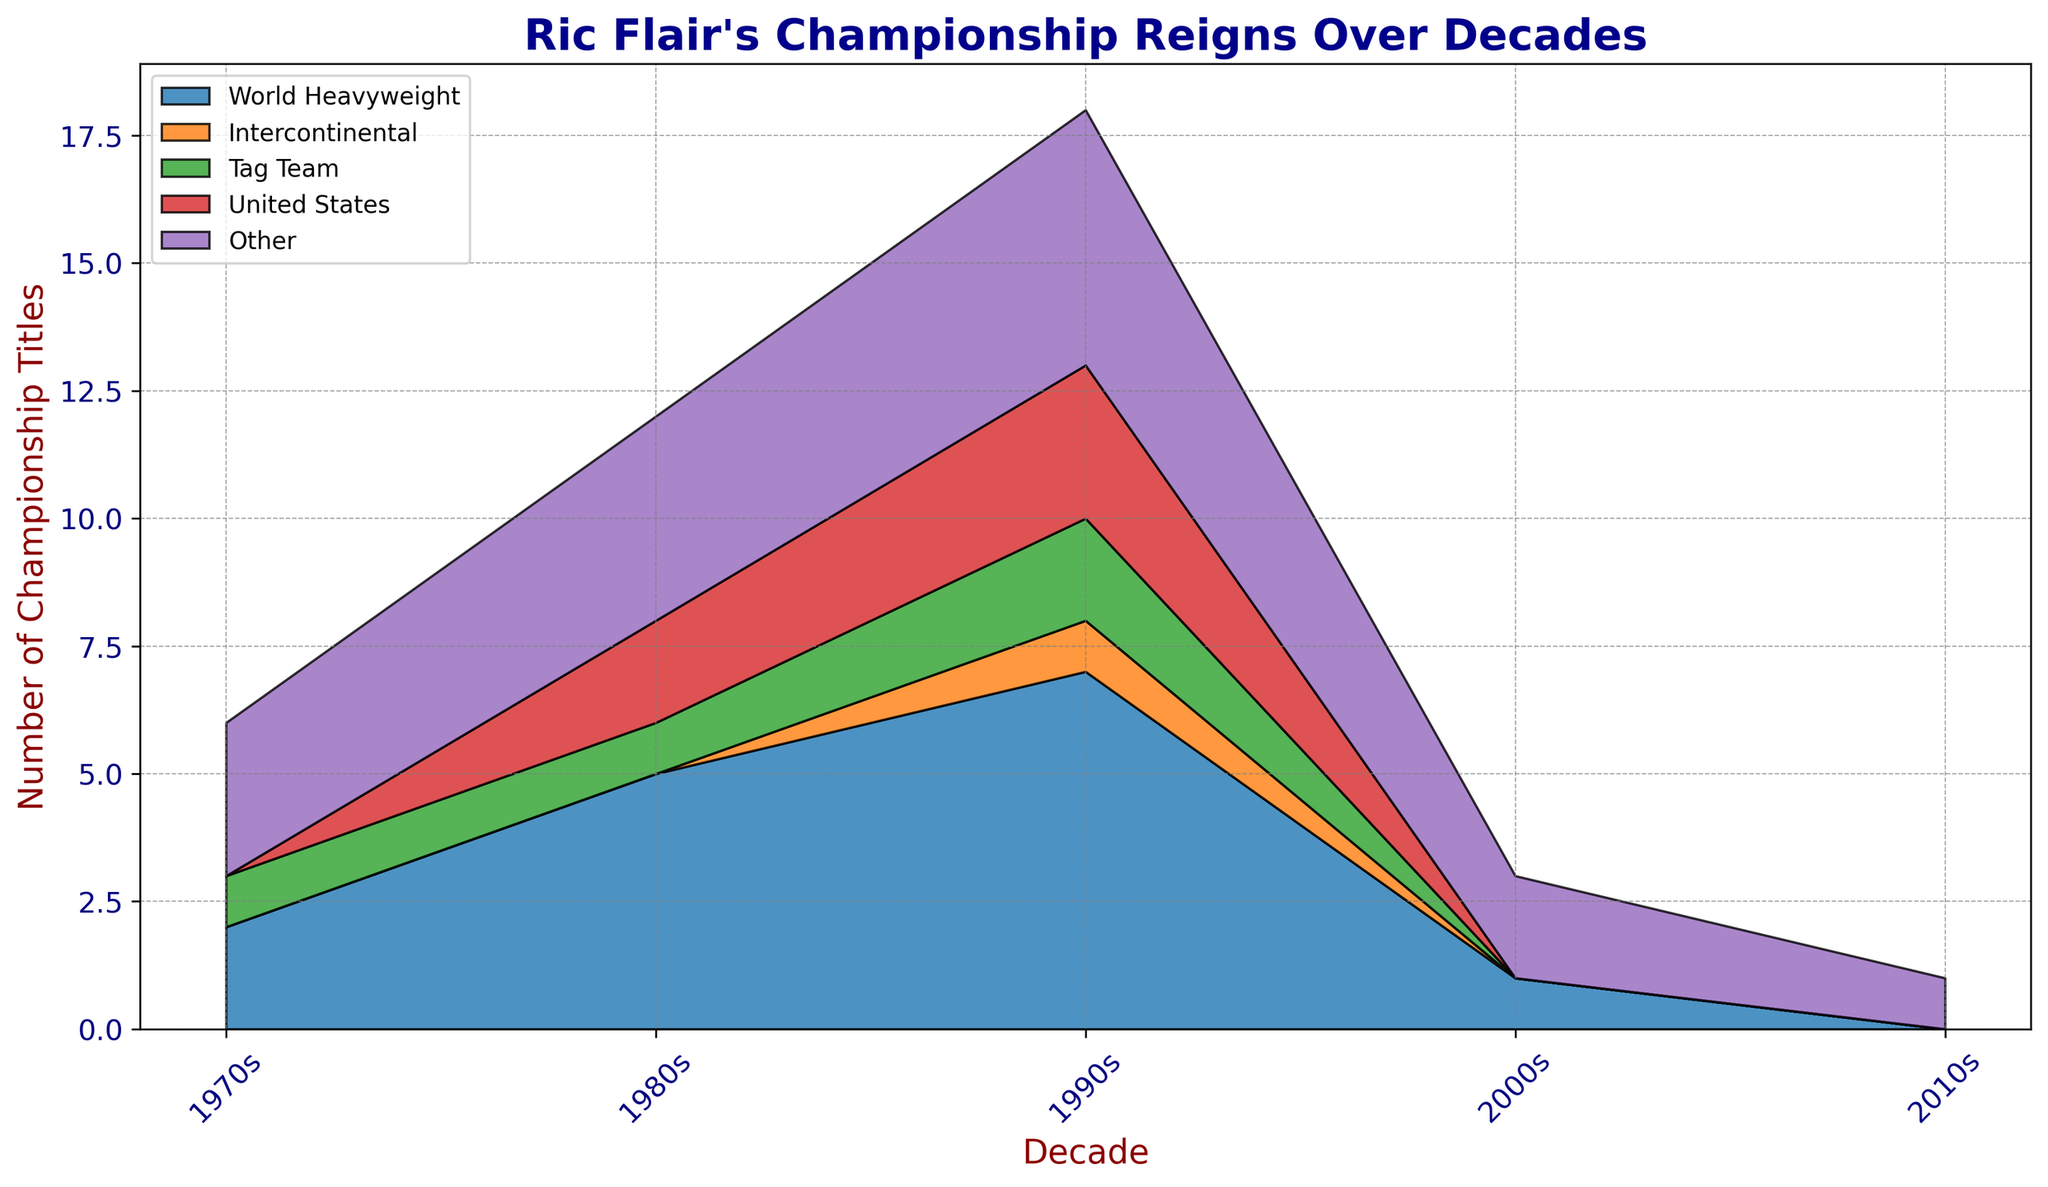What is the total number of championship titles Ric Flair won in the 1980s? To find the total number of titles in the 1980s, sum up all the values for that decade: World Heavyweight (5) + Intercontinental (0) + Tag Team (1) + United States (2) + Other (4). Therefore, 5 + 0 + 1 + 2 + 4 = 12.
Answer: 12 How many more World Heavyweight titles did Ric Flair win in the 1990s compared to the 2000s? To determine the difference, subtract the number of World Heavyweight titles in the 2000s from the number in the 1990s: 7 (1990s) - 1 (2000s).
Answer: 6 Which decade saw the highest number of United States Championship reigns? Look at the United States category across all decades and identify the highest value, which is in the 1990s with 3 titles.
Answer: 1990s In which decades did Ric Flair win at least one Tag Team Championship? Observe the Tag Team category for all decades and note the ones with values greater than zero: 1970s (1), 1980s (1), 1990s (2).
Answer: 1970s, 1980s, 1990s What is the total number of titles, across all categories, that Ric Flair won in the 1970s and 2010s combined? Sum up all title values for both decades: 
1970s: 2 (World Heavyweight) + 0 (Intercontinental) + 1 (Tag Team) + 0 (United States) + 3 (Other) = 6 
2010s: 0 (World Heavyweight) + 0 (Intercontinental) + 0 (Tag Team) + 0 (United States) + 1 (Other) = 1 
Then add the totals of both decades: 6 + 1 = 7.
Answer: 7 How does the number of Intercontinental titles in the 1990s compare to other decades? The figure shows 1 Intercontinental title in the 1990s. All other decades (1970s, 1980s, 2000s, 2010s) have 0. Thus, the 1990s have more Intercontinental titles compared to any other decade.
Answer: More in the 1990s What is the average number of "Other" titles won per decade? Sum the number of "Other" titles and divide by the number of decades: 3 (1970s) + 4 (1980s) + 5 (1990s) + 2 (2000s) + 1 (2010s) = 15. There are 5 decades, so the average is 15/5 = 3.
Answer: 3 During which decade did Ric Flair achieve the most total title reigns? Sum the titles for each decade and compare the sums:
1970s: 2 + 0 + 1 + 0 + 3 = 6,
1980s: 5 + 0 + 1 + 2 + 4 = 12,
1990s: 7 + 1 + 2 + 3 + 5 = 18,
2000s: 1 + 0 + 0 + 0 + 2 = 3,
2010s: 0 + 0 + 0 + 0 + 1 = 1.
The decade with the highest sum is the 1990s with 18.
Answer: 1990s Which title type remained zero or unchanged throughout multiple decades? Look at the titles across all decades and identify the ones with consistent zero values: Intercontinental titles remain 0 in the 1970s, 1980s, 2000s, and 2010s.
Answer: Intercontinental Titles How did the number of United States titles change between the 1980s and 2000s? Compare the number of United States titles in these decades: 2 titles in the 1980s and 0 titles in the 2000s, which indicates a decrease of 2 titles.
Answer: Decrease by 2 